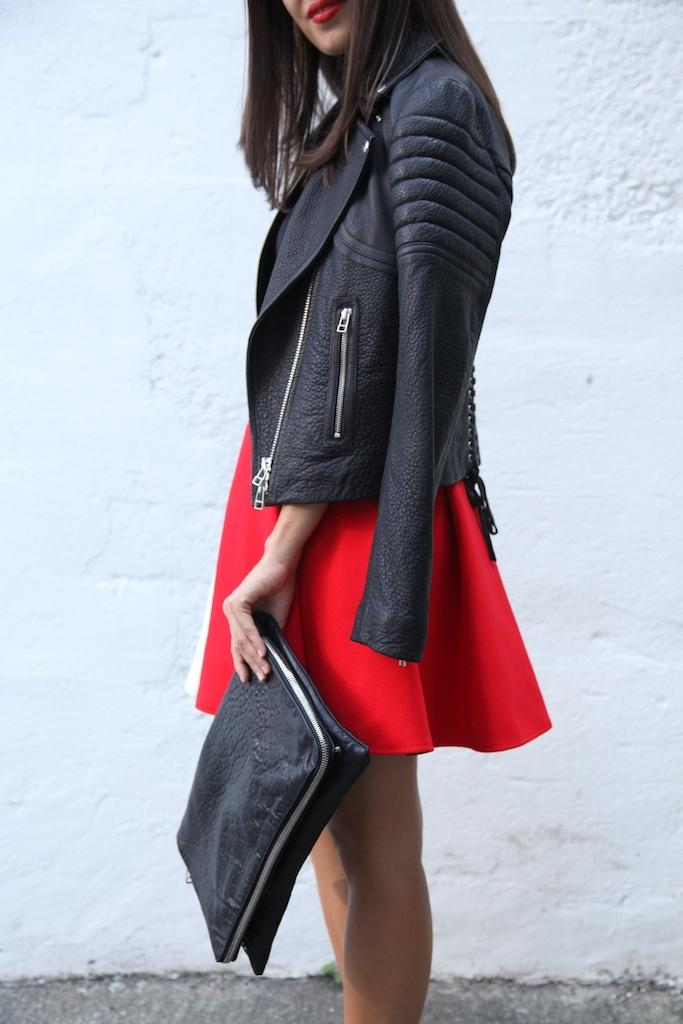Who is the main subject in the image? There is a girl in the image. What is the girl wearing? The girl is wearing a black jacket. Where is the girl standing? The girl is standing on a path. What is the girl holding in her hand? The girl is holding an object. What can be seen in the background of the image? There is a white wall in the background of the image. Does the girl have a sister in the image? There is no information about a sister in the image. How many hands does the girl have in the image? The girl has two hands in the image, but we cannot determine the exact number of hands from the image alone. 